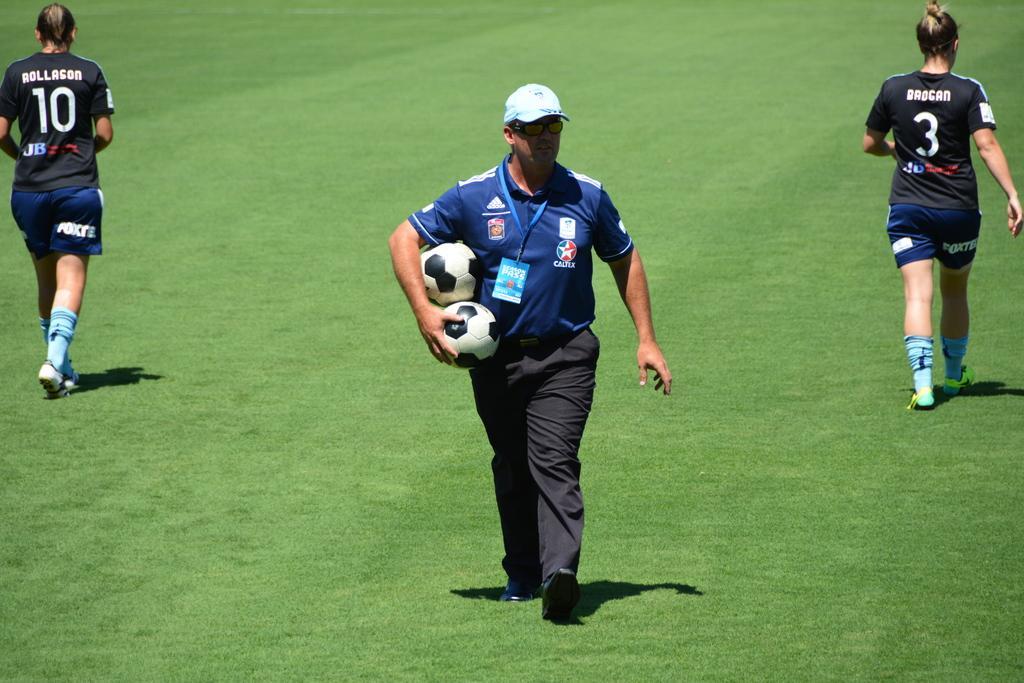Can you describe this image briefly? In the image we can see there are people who are standing on the ground and the ground is covered with grass. The man in the middle is holding balls in his hand. 